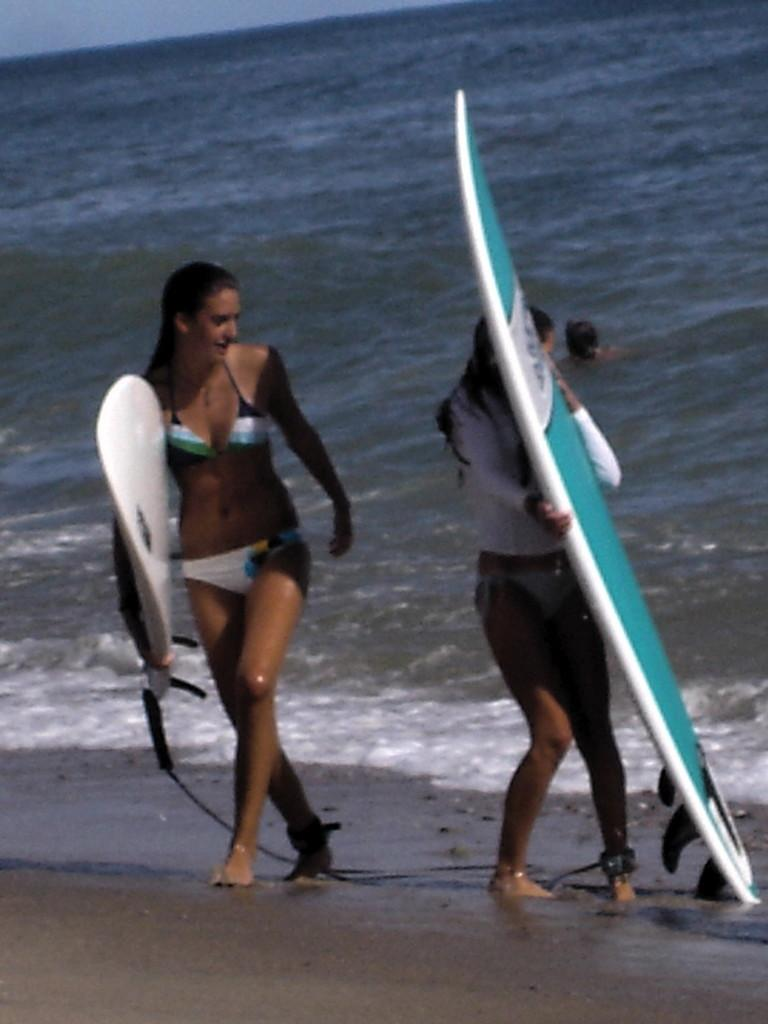How many people are in the image? There are two persons in the image. What are the two persons holding in the image? The two persons are holding a surfing board. How are they holding the surfing board? They are holding the surfing board with their hands. What type of water body is visible in the image? The image contains a body of water, which is identified as sea. What type of bird can be seen flying over the sea in the image? There is no bird visible in the image; it only shows two persons holding a surfing board. 